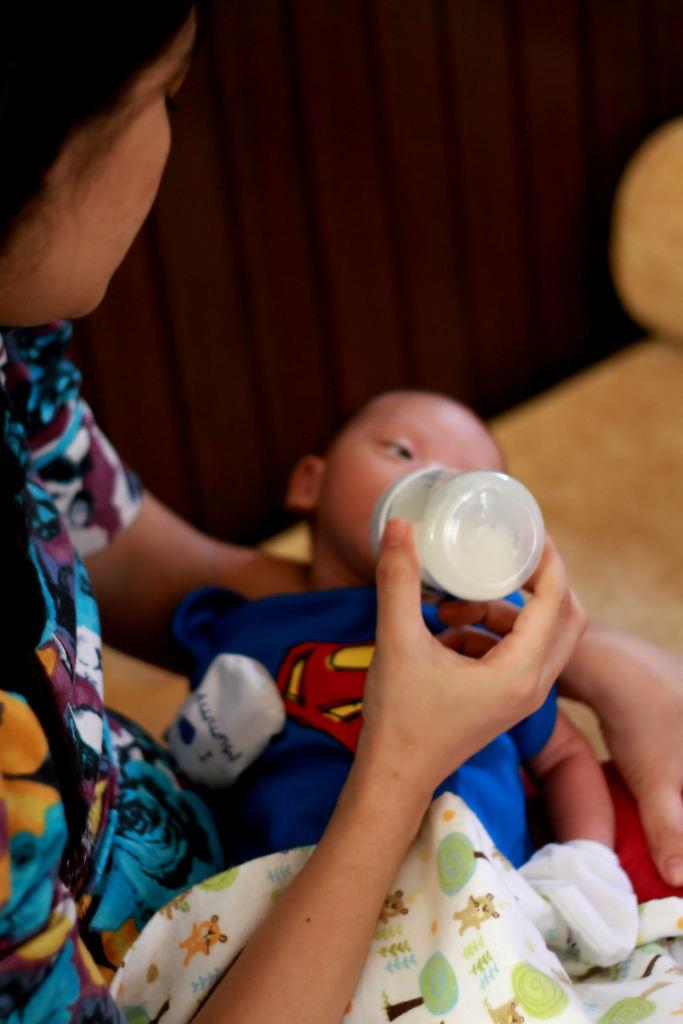Who is the main subject in the image? There is a woman in the image. What is the woman holding in the image? The woman is holding a milk bottle. What is the woman doing with the milk bottle? The woman is feeding a baby. Where is the baby located in the image? The baby is in the woman's lap. What type of snails can be seen celebrating the baby's birthday in the image? There are no snails or birthday celebrations present in the image. 